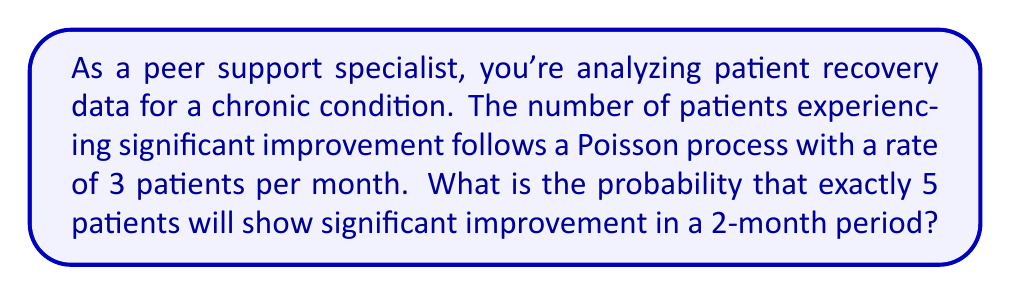Can you answer this question? Let's approach this step-by-step:

1) We're dealing with a Poisson process with a rate of λ = 3 patients per month.

2) The time period we're considering is 2 months. For a Poisson process, the rate scales linearly with time. So for 2 months, our rate becomes:
   λ' = 3 * 2 = 6 patients per 2 months

3) We want to find the probability of exactly 5 patients showing improvement in this 2-month period. This follows a Poisson distribution with mean λ' = 6.

4) The probability mass function for a Poisson distribution is:

   $$P(X = k) = \frac{e^{-λ} λ^k}{k!}$$

   where λ is the mean and k is the number of events.

5) In our case, λ = 6 and k = 5. Let's substitute these values:

   $$P(X = 5) = \frac{e^{-6} 6^5}{5!}$$

6) Now let's calculate this:
   
   $$P(X = 5) = \frac{e^{-6} * 7776}{120} \approx 0.1606$$

7) Converting to a percentage: 0.1606 * 100 ≈ 16.06%
Answer: 16.06% 